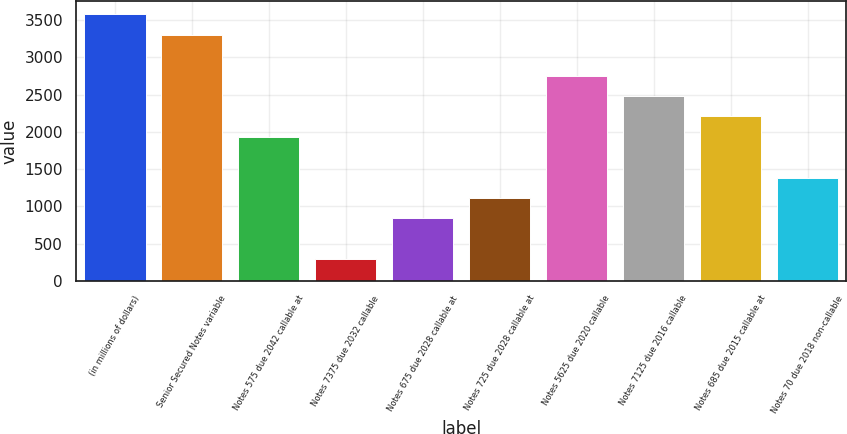Convert chart. <chart><loc_0><loc_0><loc_500><loc_500><bar_chart><fcel>(in millions of dollars)<fcel>Senior Secured Notes variable<fcel>Notes 575 due 2042 callable at<fcel>Notes 7375 due 2032 callable<fcel>Notes 675 due 2028 callable at<fcel>Notes 725 due 2028 callable at<fcel>Notes 5625 due 2020 callable<fcel>Notes 7125 due 2016 callable<fcel>Notes 685 due 2015 callable at<fcel>Notes 70 due 2018 non-callable<nl><fcel>3577.4<fcel>3303.4<fcel>1933.4<fcel>289.4<fcel>837.4<fcel>1111.4<fcel>2755.4<fcel>2481.4<fcel>2207.4<fcel>1385.4<nl></chart> 